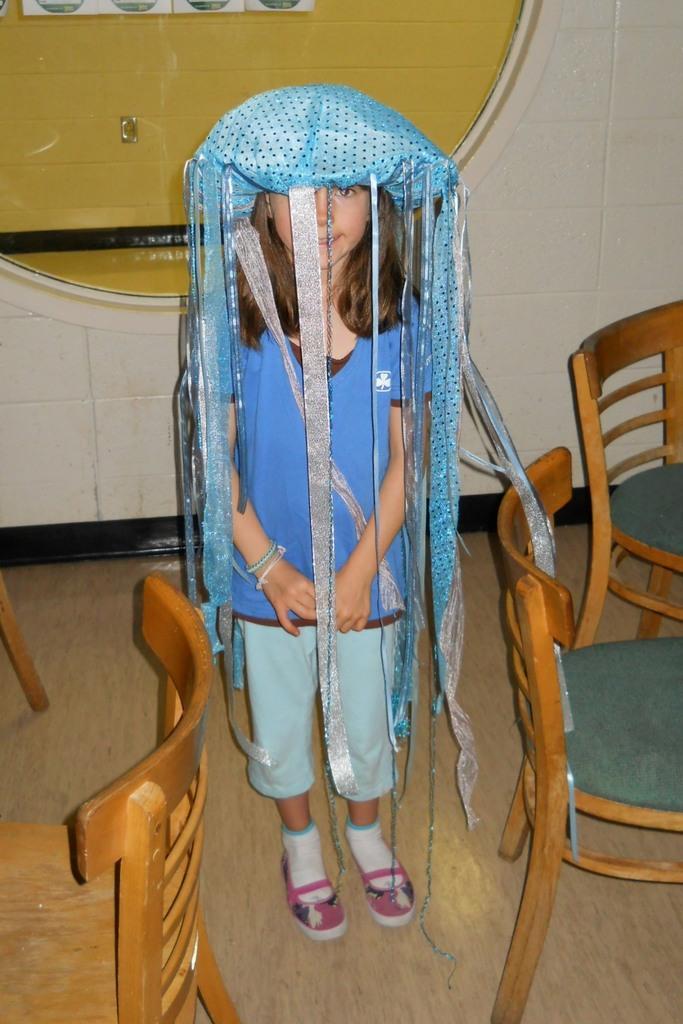How would you summarize this image in a sentence or two? In this image I see a girl who is standing and there are few chairs over here and In the background I see the wall. 